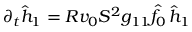<formula> <loc_0><loc_0><loc_500><loc_500>\partial _ { t } \hat { h } _ { 1 } = R v _ { 0 } S ^ { 2 } g _ { 1 1 } \hat { f } _ { 0 } \, \hat { h } _ { 1 }</formula> 